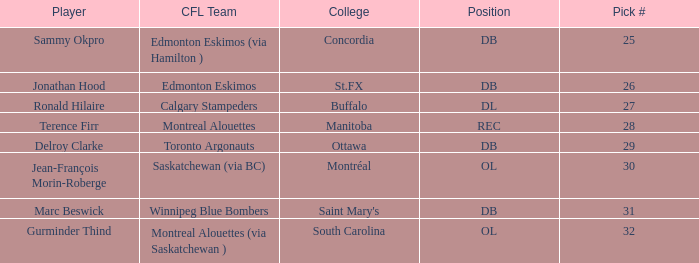In the cfl, which team has a pick number exceeding 31? Montreal Alouettes (via Saskatchewan ). 